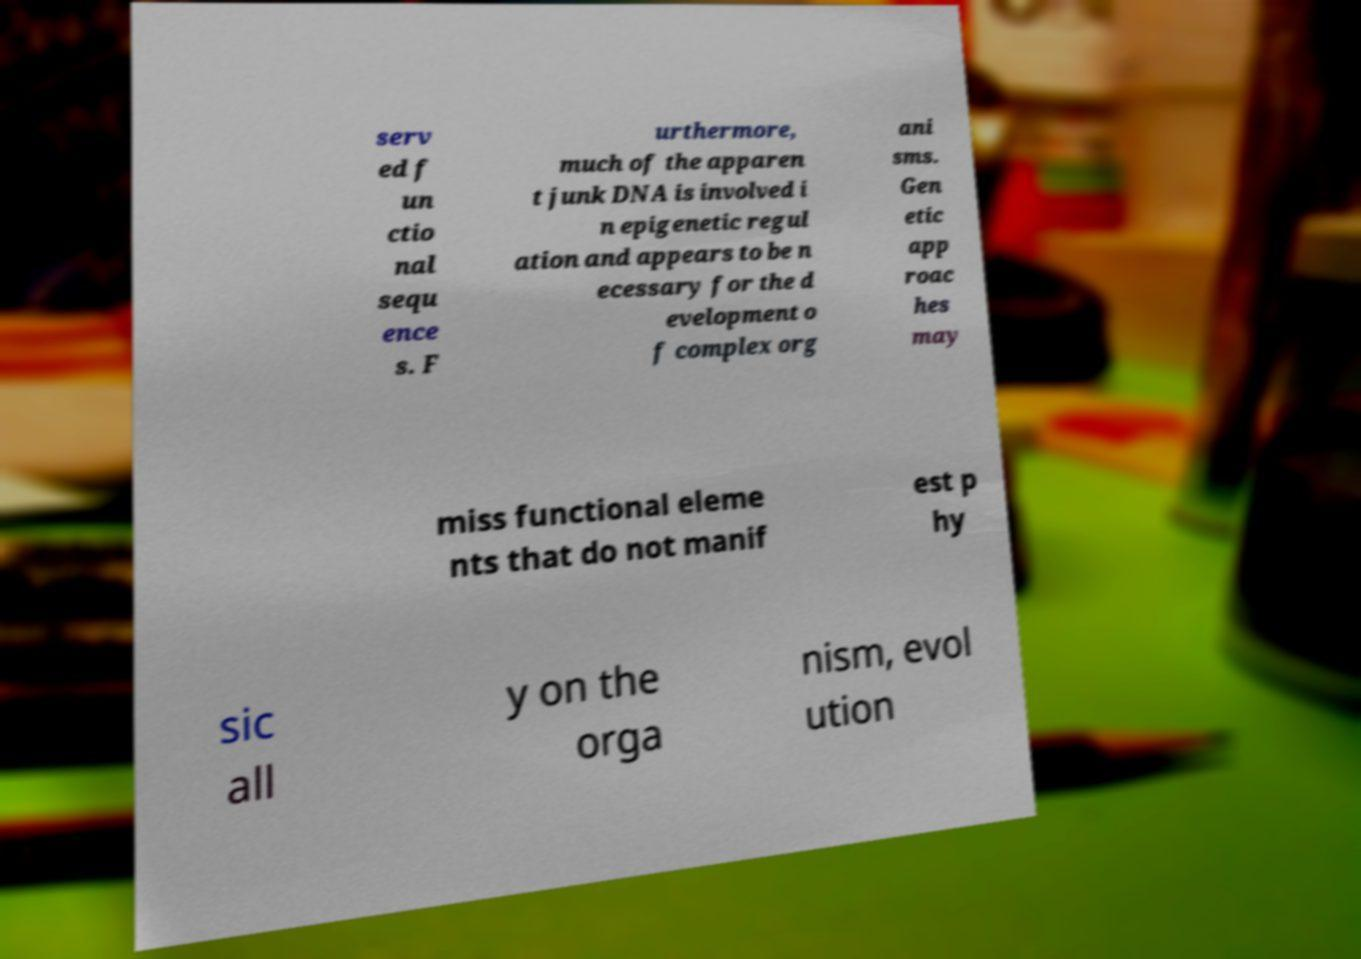There's text embedded in this image that I need extracted. Can you transcribe it verbatim? serv ed f un ctio nal sequ ence s. F urthermore, much of the apparen t junk DNA is involved i n epigenetic regul ation and appears to be n ecessary for the d evelopment o f complex org ani sms. Gen etic app roac hes may miss functional eleme nts that do not manif est p hy sic all y on the orga nism, evol ution 